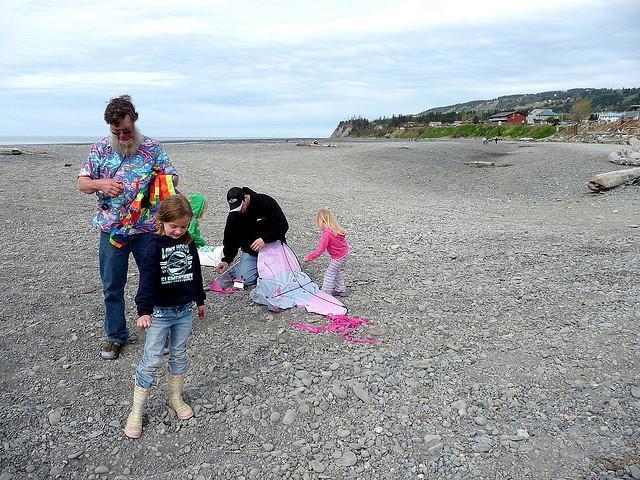How many people in this group are female?
Give a very brief answer. 2. How many people are there?
Give a very brief answer. 3. 